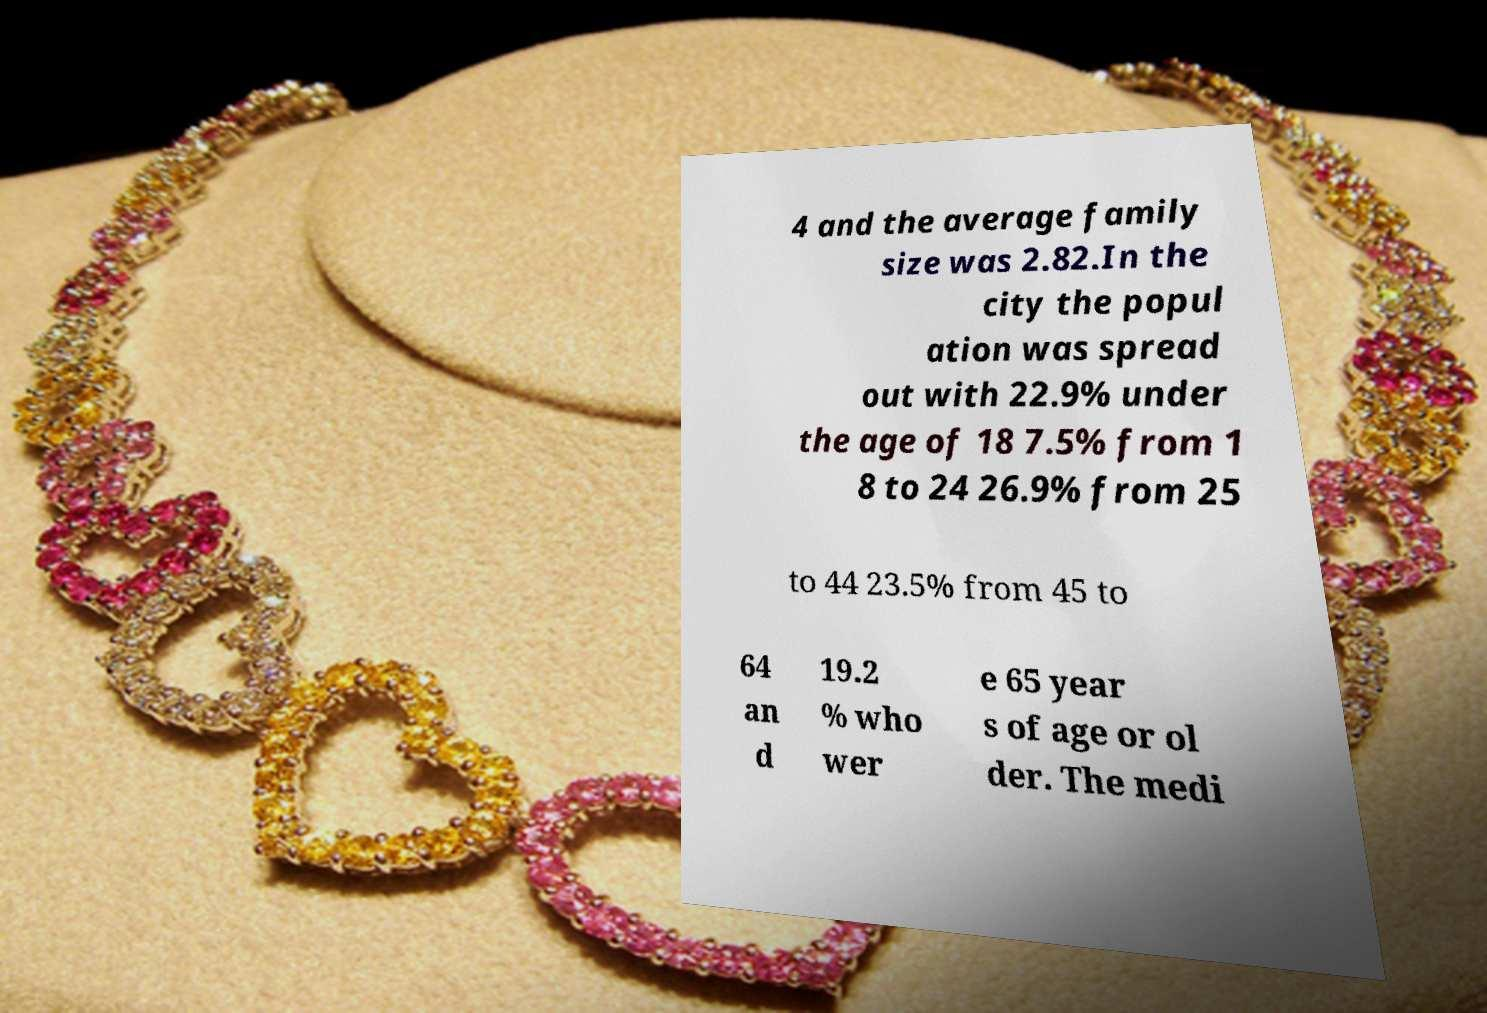Please read and relay the text visible in this image. What does it say? 4 and the average family size was 2.82.In the city the popul ation was spread out with 22.9% under the age of 18 7.5% from 1 8 to 24 26.9% from 25 to 44 23.5% from 45 to 64 an d 19.2 % who wer e 65 year s of age or ol der. The medi 